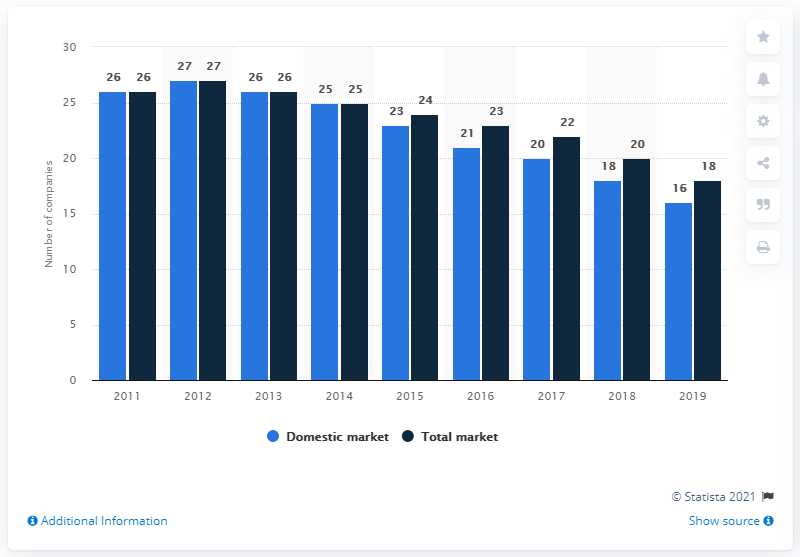List a handful of essential elements in this visual. According to data from 2019, approximately 16 companies were present on the Croatian domestic market. In 2011, there were 26 companies operating on the Croatian insurance market. In 2019, there were a total of 18 companies operating on the market. 